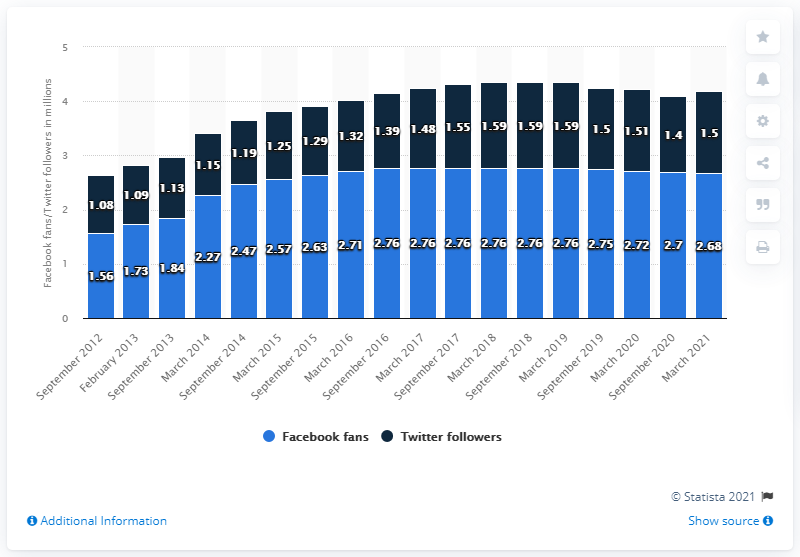Outline some significant characteristics in this image. The number of followers that is greater than 1.5 million is more than 5 times. The number of followers surpassed 1.5 million in September 2017. The number of Facebook followers that the Orlando Magic basketball team had in March 2021 was 2,680. The Orlando Magic had their Facebook page created in September 2012. 